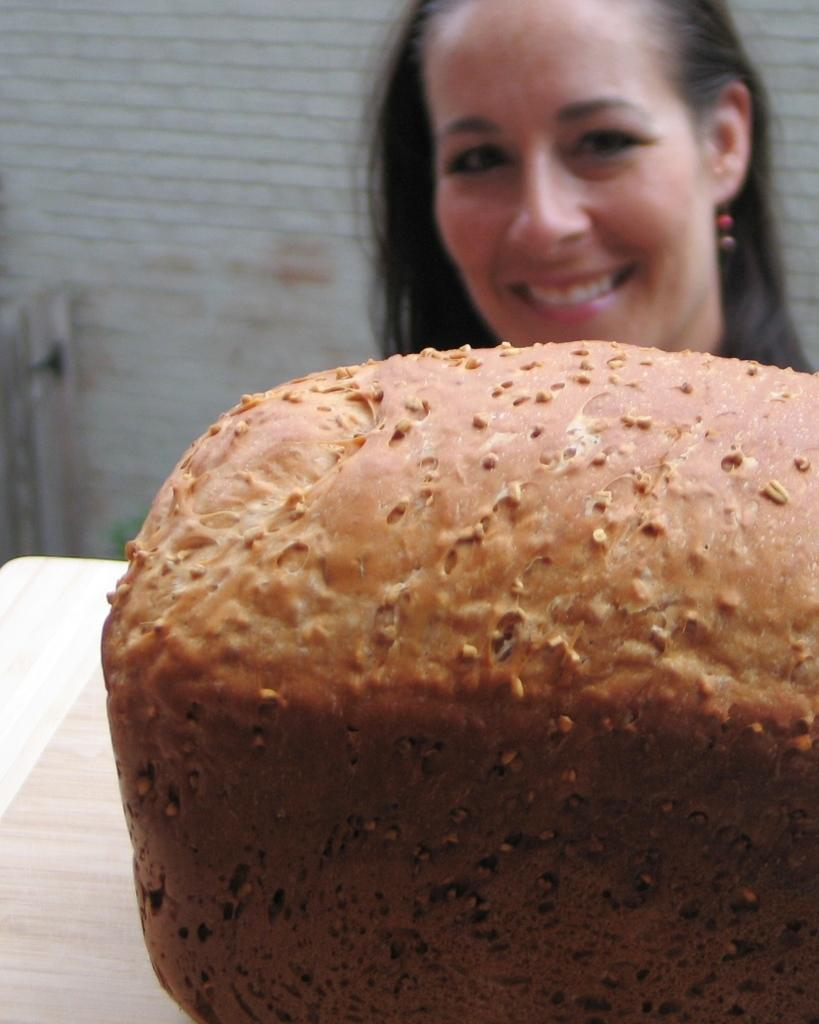Who is present in the image? There is a woman in the image. What is the woman doing in the image? The woman is smiling in the image. What is located in front of the woman? There is a brown-colored bread in front of the woman. What can be seen in the background of the image? There is a white-colored wall in the background of the image. What type of plant is growing on the woman's head in the image? There is no plant growing on the woman's head in the image. 